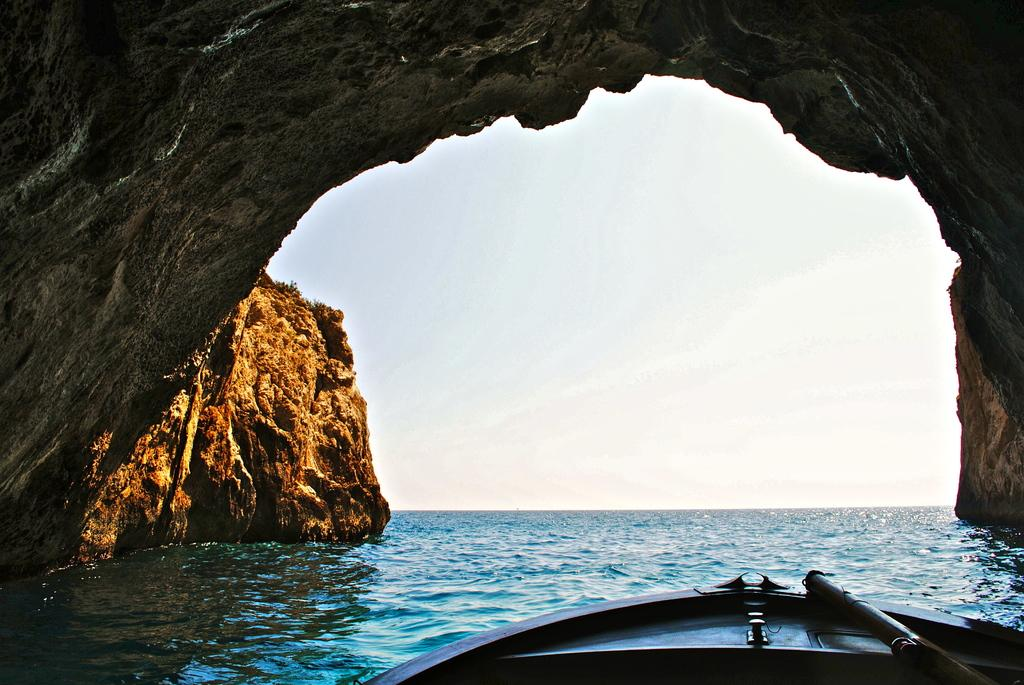What type of landscape is depicted in the image? The image appears to depict hills. What natural feature can be seen in the hills? There is a cave in the image. What is happening with the water in the image? Water is flowing in the image. What type of vehicle is present at the bottom of the image? There is a boat at the bottom of the image. What part of the natural environment is visible in the image? The sky is visible in the image. What type of needle is being used to sew the boat in the image? There is no needle present in the image, and the boat is not being sewn. How does the authority figure in the image control the flow of water? There is no authority figure present in the image, and the flow of water is a natural occurrence. 